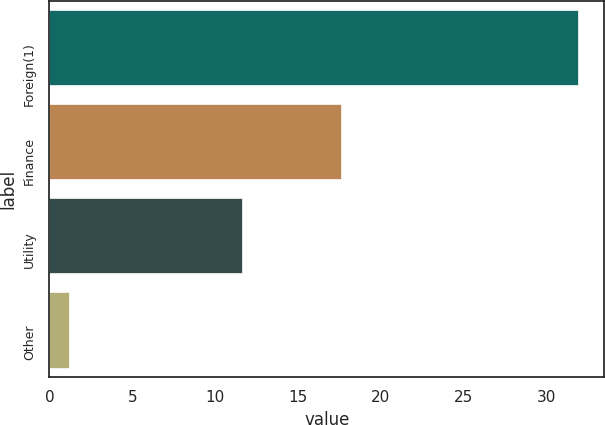<chart> <loc_0><loc_0><loc_500><loc_500><bar_chart><fcel>Foreign(1)<fcel>Finance<fcel>Utility<fcel>Other<nl><fcel>31.9<fcel>17.6<fcel>11.6<fcel>1.2<nl></chart> 